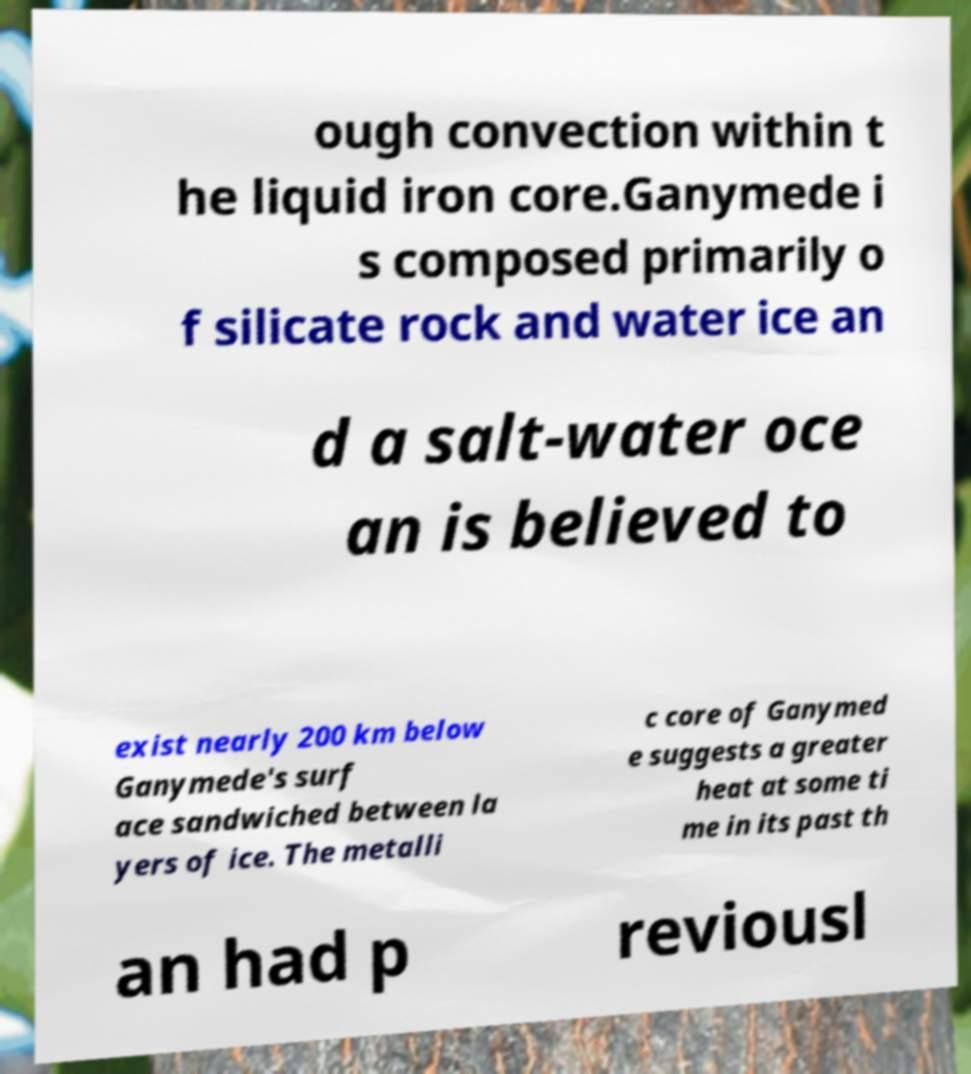Could you assist in decoding the text presented in this image and type it out clearly? ough convection within t he liquid iron core.Ganymede i s composed primarily o f silicate rock and water ice an d a salt-water oce an is believed to exist nearly 200 km below Ganymede's surf ace sandwiched between la yers of ice. The metalli c core of Ganymed e suggests a greater heat at some ti me in its past th an had p reviousl 